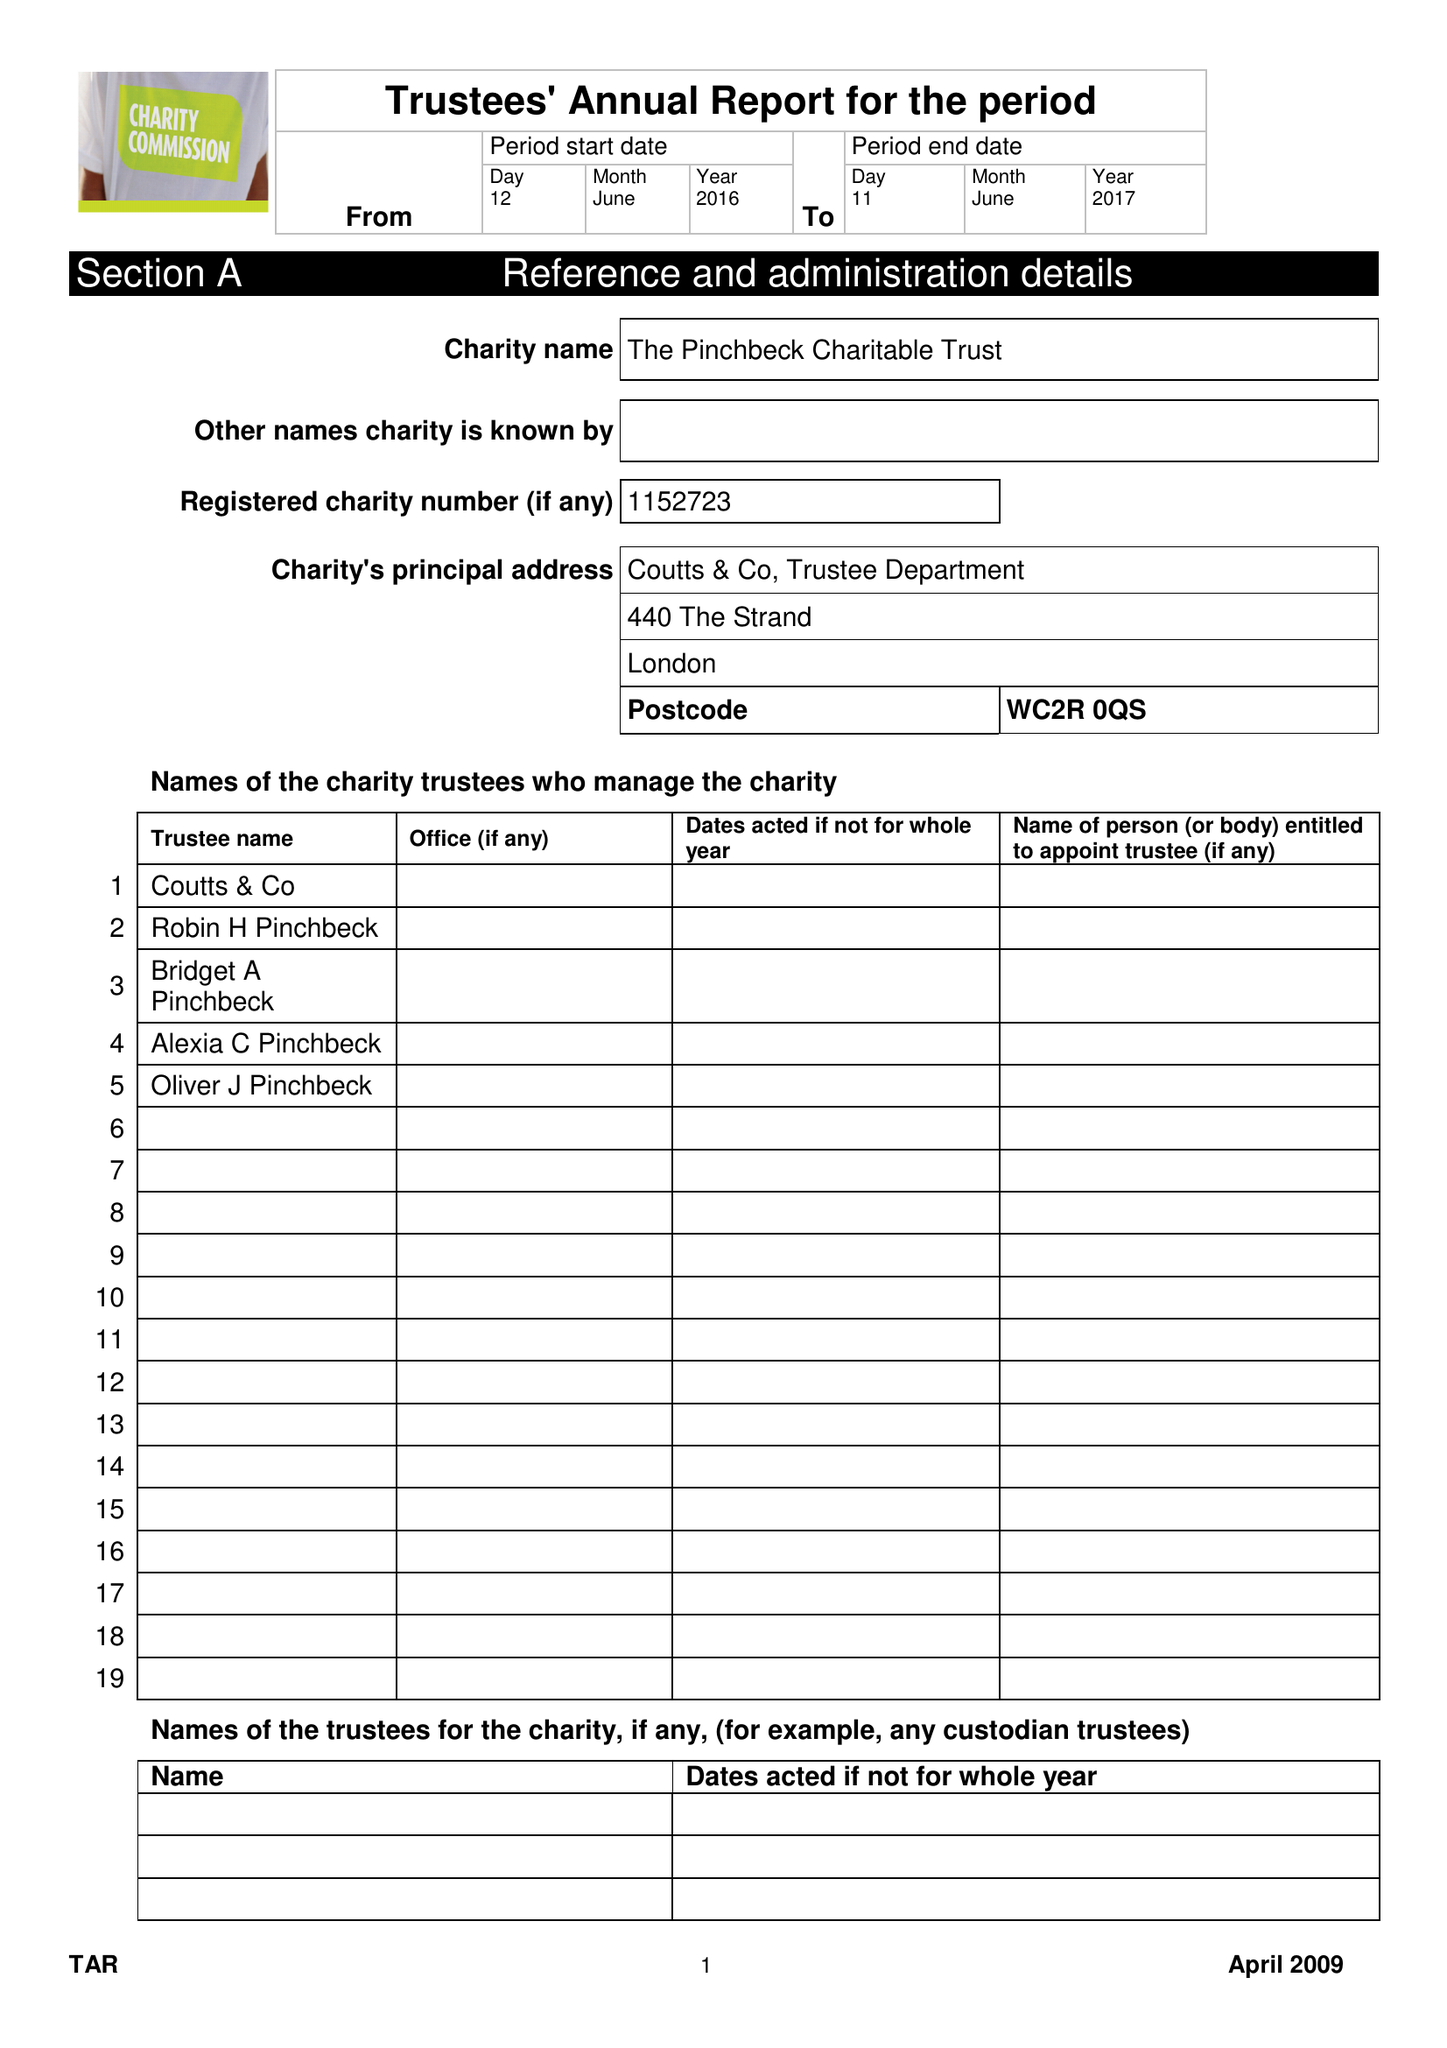What is the value for the spending_annually_in_british_pounds?
Answer the question using a single word or phrase. 59418.00 